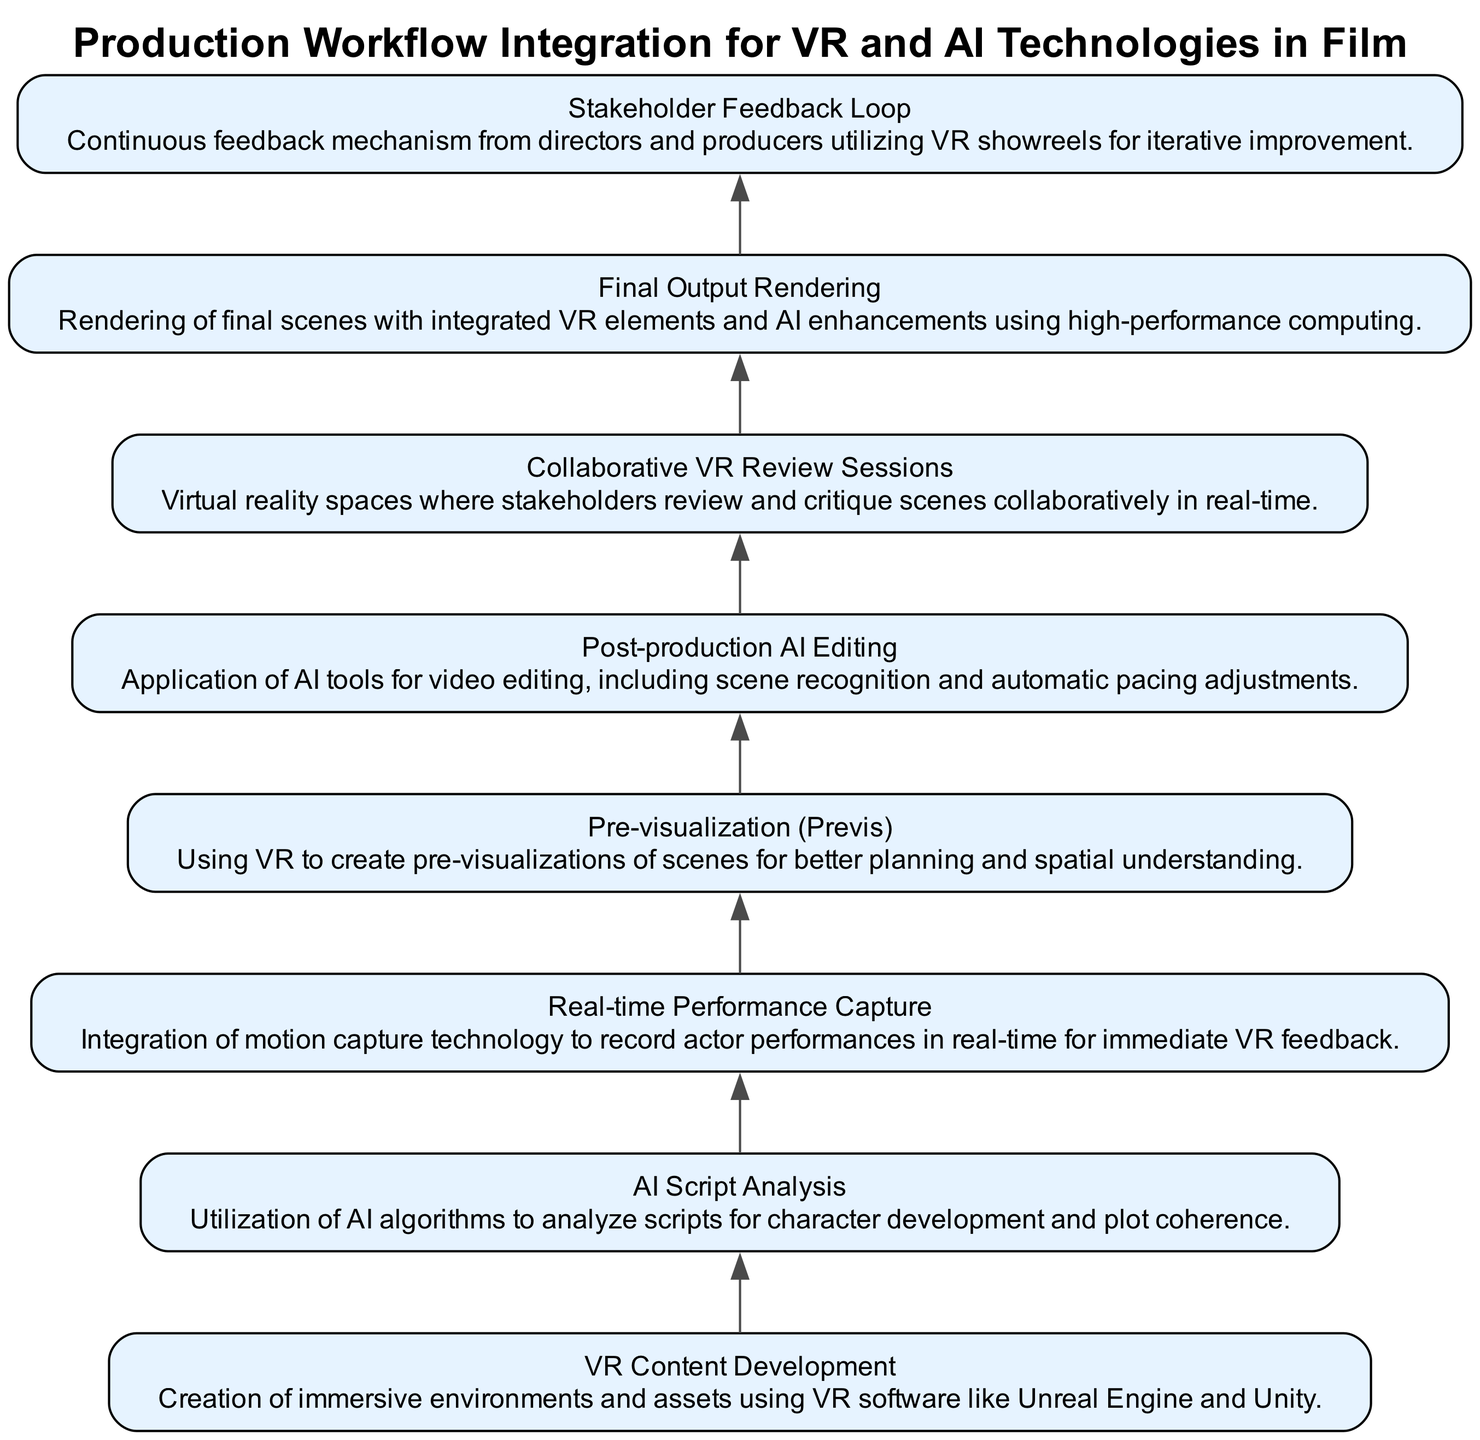What is the first node in the flow chart? The first node is "VR Content Development" as it appears at the bottom and serves as the starting point of the chart. This is determined by identifying the first entry in the list of nodes.
Answer: VR Content Development How many key activities are listed in the flow chart? The flow chart consists of eight nodes that represent key activities, which can be counted directly from the provided data elements.
Answer: 8 What is the last activity in the production workflow? The last activity in the flow chart is "Final Output Rendering," as it is positioned at the top of the chart and follows all other activities.
Answer: Final Output Rendering Which activity uses AI for analysis? The activity "AI Script Analysis" explicitly mentions the utilization of AI algorithms for analyzing scripts, thus identifying it clearly among the options.
Answer: AI Script Analysis What is the relationship between "Stakeholder Feedback Loop" and "Collaborative VR Review Sessions"? The "Stakeholder Feedback Loop" node cannot exist independently in the diagram and is placed after "Collaborative VR Review Sessions," highlighting that stakeholder feedback is gained after collaboration.
Answer: Feedback follows review What potential integration does "Real-time Performance Capture" have in relation to "Pre-visualization (Previs)"? "Real-time Performance Capture" feeds actor performances directly into the creative process, which benefits "Pre-visualization (Previs)" by providing accurate data for immersive scene creation, thus establishing a connection.
Answer: Enhances scene accuracy Which two activities are primarily focused on editing and feedback processes? The two activities focused on editing and feedback are "Post-production AI Editing" and "Stakeholder Feedback Loop,” as one describes the editing operation and the latter describes feedback collection in the production process.
Answer: Post-production AI Editing, Stakeholder Feedback Loop What type of technology does "Final Output Rendering" require? "Final Output Rendering" requires high-performance computing as specified in its description, indicating the necessity of advanced computational power for this activity.
Answer: High-performance computing What is the primary focus of "Collaborative VR Review Sessions"? The primary focus is to facilitate a real-time collaborative environment in VR for stakeholders to review and critique scenes, as described in its definition.
Answer: Real-time collaboration 